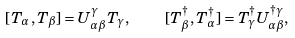<formula> <loc_0><loc_0><loc_500><loc_500>[ T _ { \alpha } , T _ { \beta } ] = U ^ { \gamma } _ { \alpha \beta } T _ { \gamma } , \quad [ T ^ { \dagger } _ { \beta } , T ^ { \dagger } _ { \alpha } ] = T ^ { \dagger } _ { \gamma } U ^ { \dagger \gamma } _ { \alpha \beta } ,</formula> 